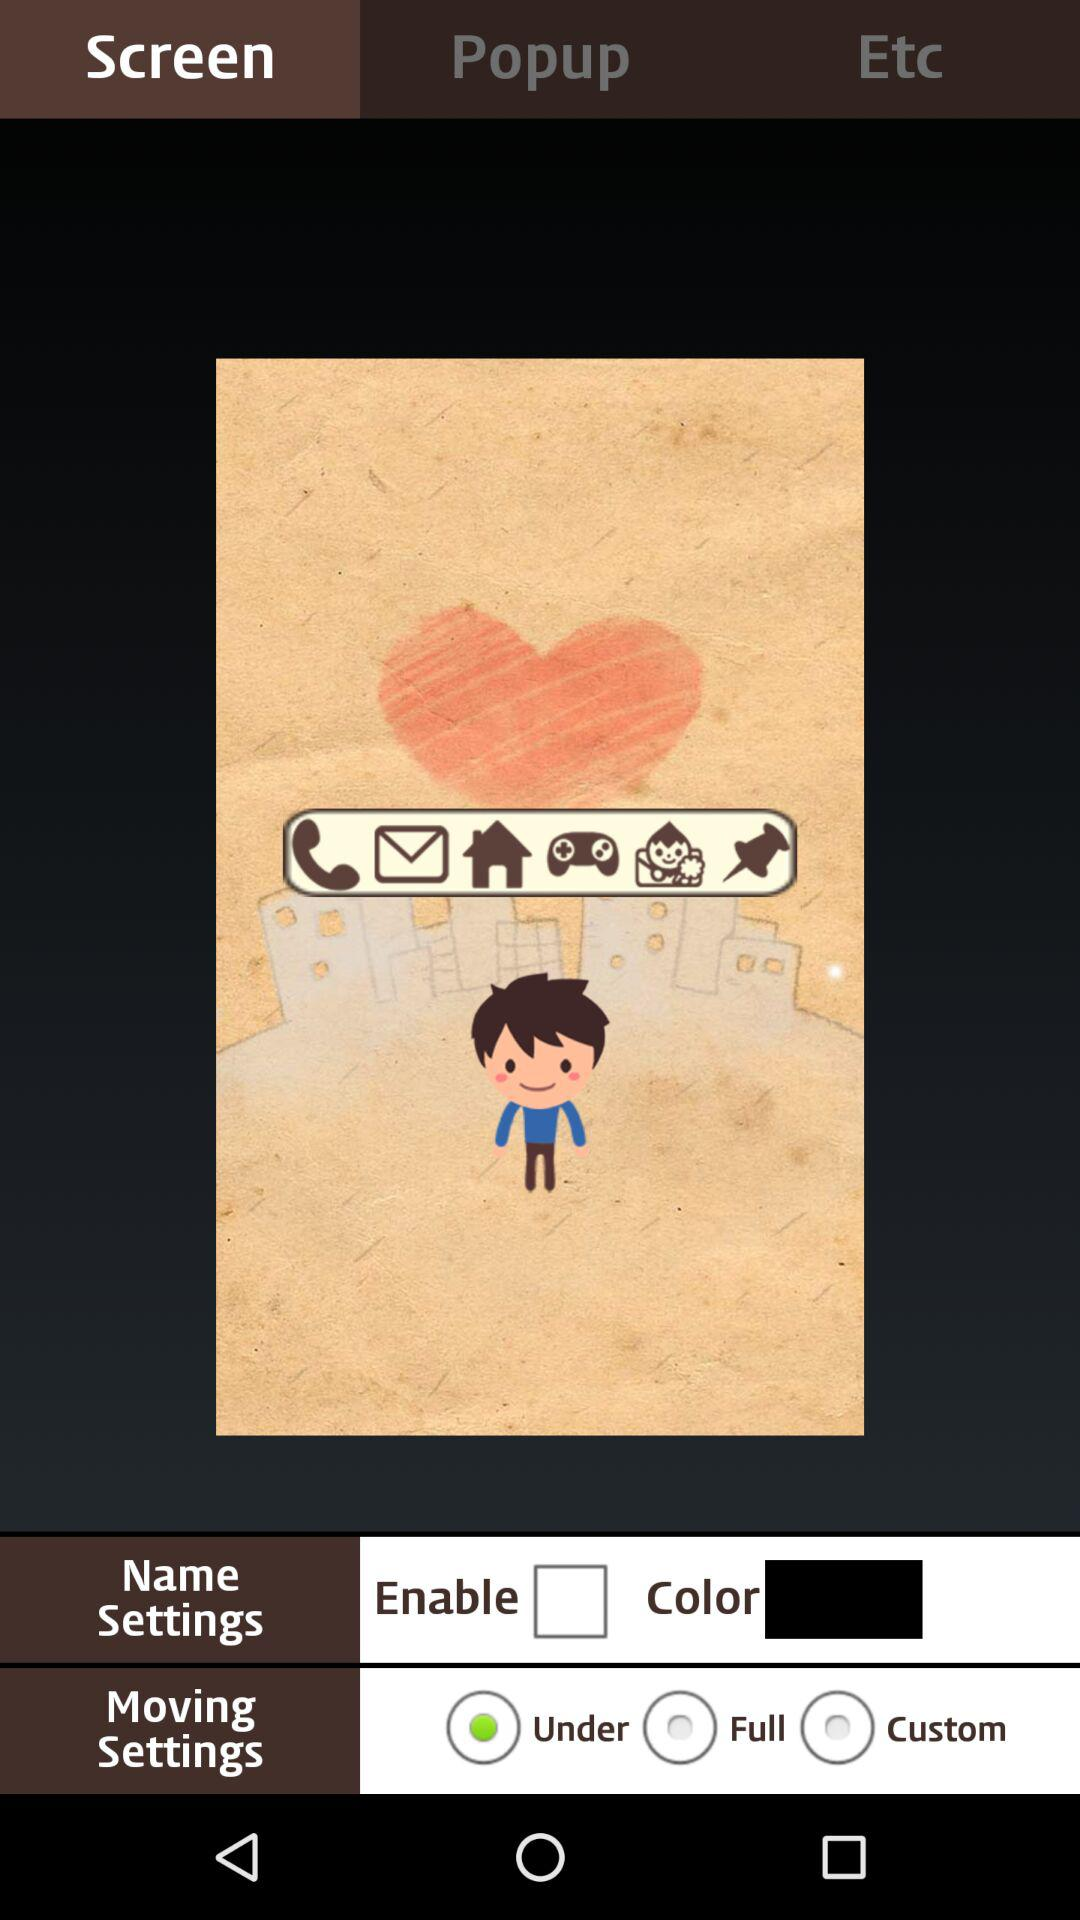What is the selected name settings?
When the provided information is insufficient, respond with <no answer>. <no answer> 